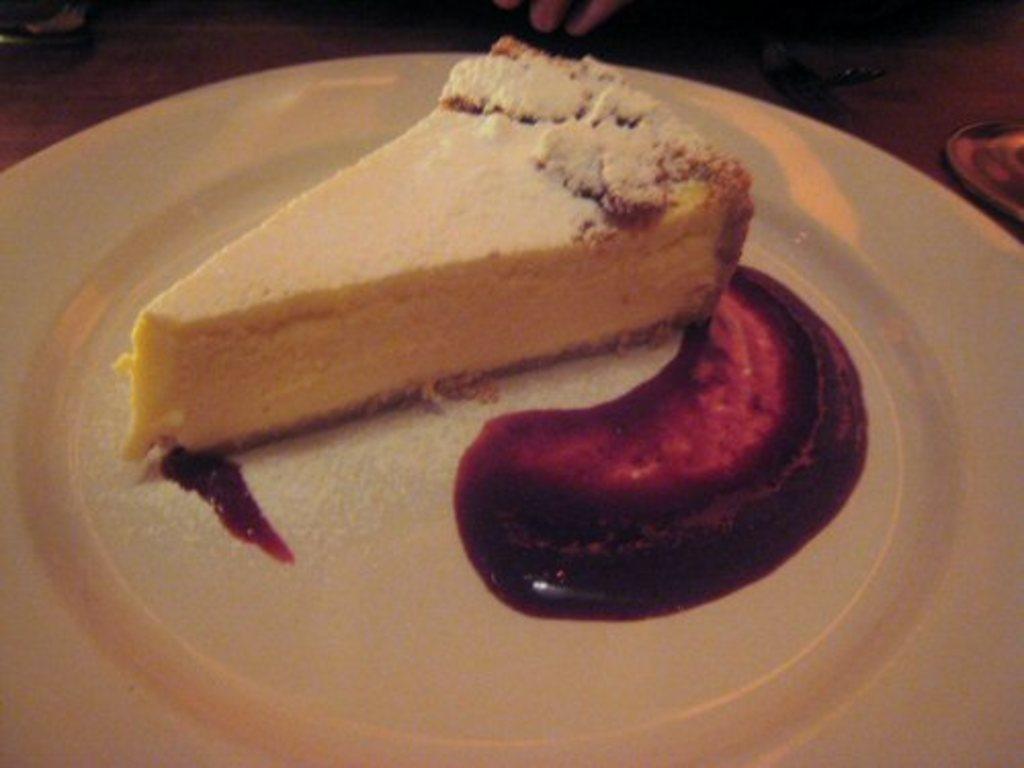Could you give a brief overview of what you see in this image? In the picture we can see a plate which is white in color, on it we can see a slice of bread and jam beside it. 